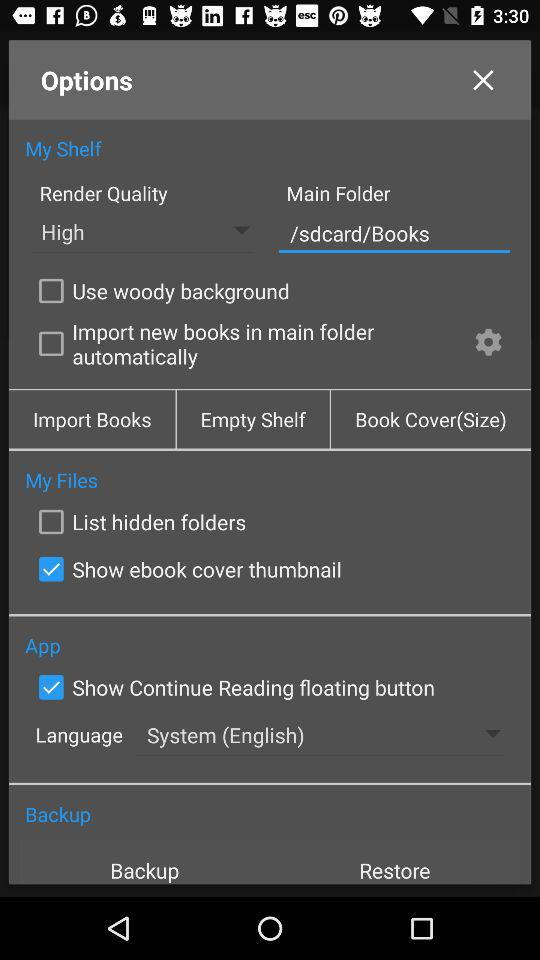How is the render quality? The render quality is high. 